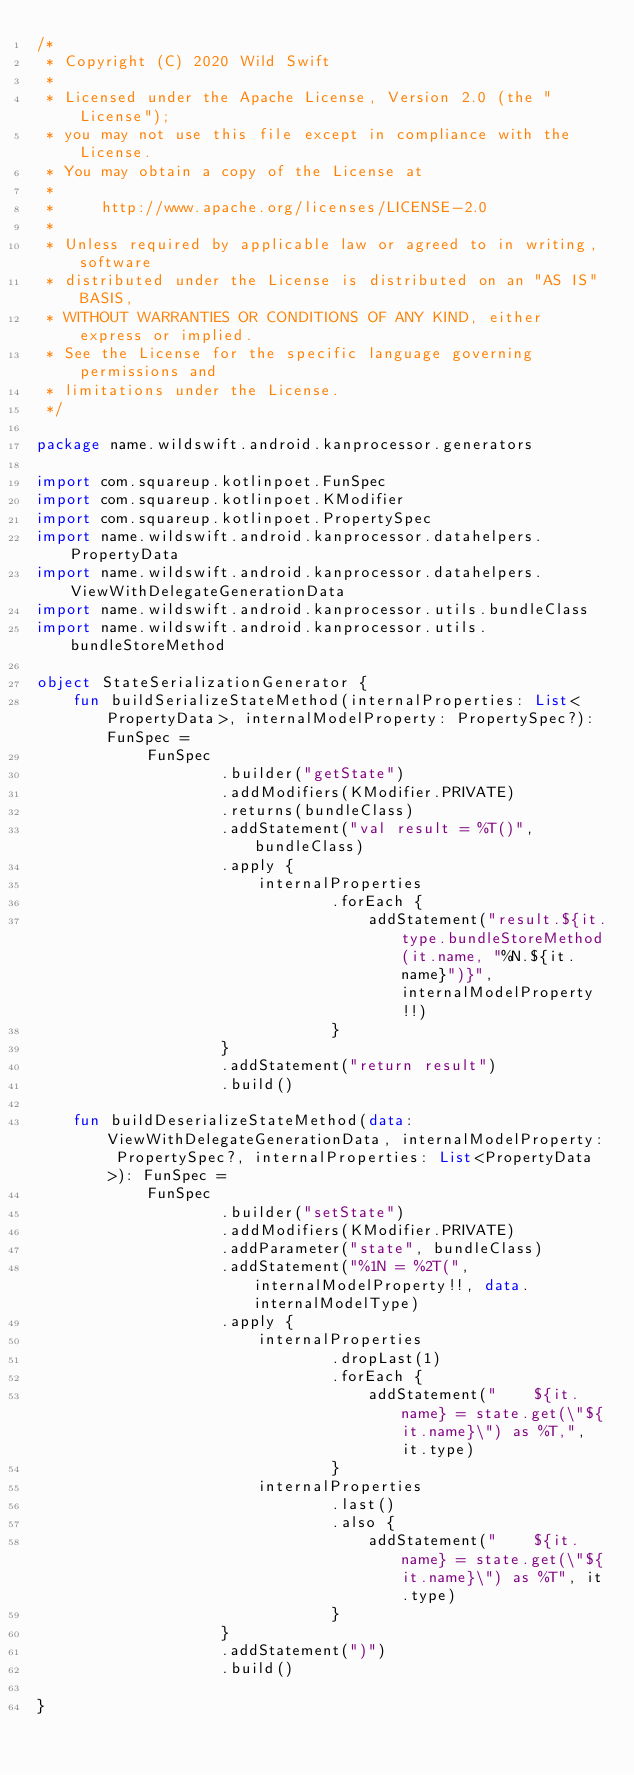<code> <loc_0><loc_0><loc_500><loc_500><_Kotlin_>/*
 * Copyright (C) 2020 Wild Swift
 *
 * Licensed under the Apache License, Version 2.0 (the "License");
 * you may not use this file except in compliance with the License.
 * You may obtain a copy of the License at
 *
 *     http://www.apache.org/licenses/LICENSE-2.0
 *
 * Unless required by applicable law or agreed to in writing, software
 * distributed under the License is distributed on an "AS IS" BASIS,
 * WITHOUT WARRANTIES OR CONDITIONS OF ANY KIND, either express or implied.
 * See the License for the specific language governing permissions and
 * limitations under the License.
 */

package name.wildswift.android.kanprocessor.generators

import com.squareup.kotlinpoet.FunSpec
import com.squareup.kotlinpoet.KModifier
import com.squareup.kotlinpoet.PropertySpec
import name.wildswift.android.kanprocessor.datahelpers.PropertyData
import name.wildswift.android.kanprocessor.datahelpers.ViewWithDelegateGenerationData
import name.wildswift.android.kanprocessor.utils.bundleClass
import name.wildswift.android.kanprocessor.utils.bundleStoreMethod

object StateSerializationGenerator {
    fun buildSerializeStateMethod(internalProperties: List<PropertyData>, internalModelProperty: PropertySpec?): FunSpec =
            FunSpec
                    .builder("getState")
                    .addModifiers(KModifier.PRIVATE)
                    .returns(bundleClass)
                    .addStatement("val result = %T()", bundleClass)
                    .apply {
                        internalProperties
                                .forEach {
                                    addStatement("result.${it.type.bundleStoreMethod(it.name, "%N.${it.name}")}", internalModelProperty!!)
                                }
                    }
                    .addStatement("return result")
                    .build()

    fun buildDeserializeStateMethod(data: ViewWithDelegateGenerationData, internalModelProperty: PropertySpec?, internalProperties: List<PropertyData>): FunSpec =
            FunSpec
                    .builder("setState")
                    .addModifiers(KModifier.PRIVATE)
                    .addParameter("state", bundleClass)
                    .addStatement("%1N = %2T(", internalModelProperty!!, data.internalModelType)
                    .apply {
                        internalProperties
                                .dropLast(1)
                                .forEach {
                                    addStatement("    ${it.name} = state.get(\"${it.name}\") as %T,", it.type)
                                }
                        internalProperties
                                .last()
                                .also {
                                    addStatement("    ${it.name} = state.get(\"${it.name}\") as %T", it.type)
                                }
                    }
                    .addStatement(")")
                    .build()

}</code> 